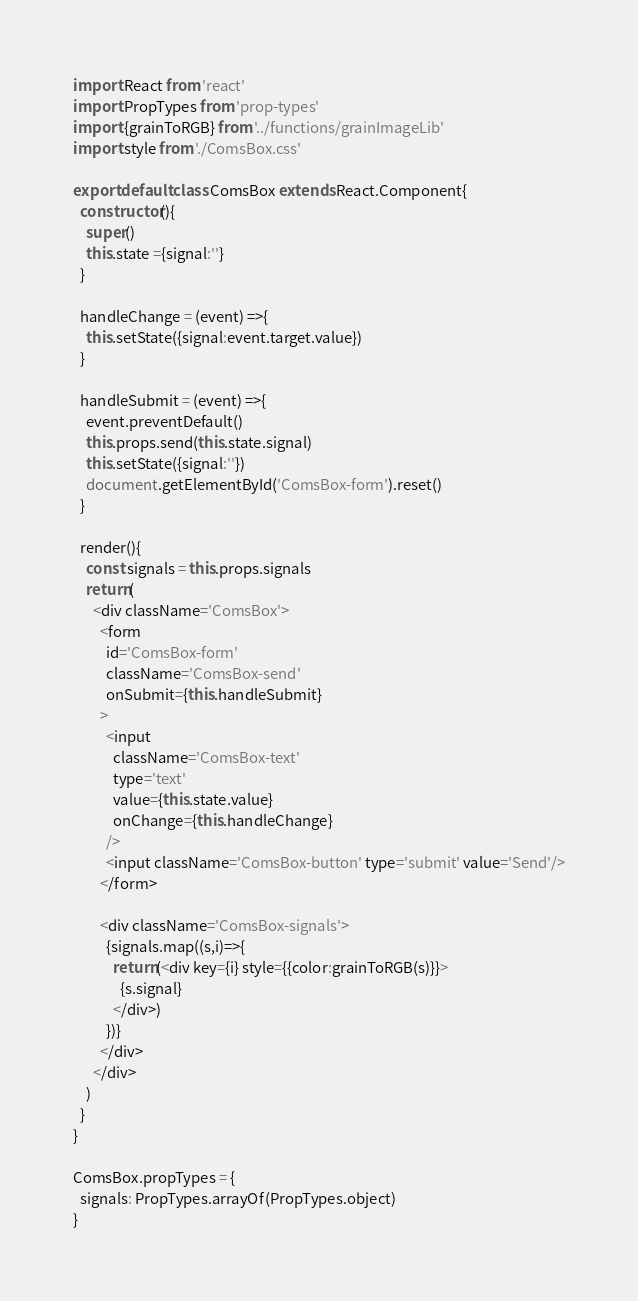<code> <loc_0><loc_0><loc_500><loc_500><_JavaScript_>import React from 'react'
import PropTypes from 'prop-types'
import {grainToRGB} from '../functions/grainImageLib'
import style from './ComsBox.css'

export default class ComsBox extends React.Component{
  constructor(){
    super()
    this.state ={signal:''}
  }

  handleChange = (event) =>{
    this.setState({signal:event.target.value})
  }
  
  handleSubmit = (event) =>{
    event.preventDefault()
    this.props.send(this.state.signal)
    this.setState({signal:''})
    document.getElementById('ComsBox-form').reset()
  }

  render(){
    const signals = this.props.signals
    return(
      <div className='ComsBox'>
        <form 
          id='ComsBox-form'
          className='ComsBox-send' 
          onSubmit={this.handleSubmit}
        >
          <input 
            className='ComsBox-text'
            type='text' 
            value={this.state.value}
            onChange={this.handleChange}
          />
          <input className='ComsBox-button' type='submit' value='Send'/>
        </form>
        
        <div className='ComsBox-signals'>
          {signals.map((s,i)=>{
            return(<div key={i} style={{color:grainToRGB(s)}}>
              {s.signal}
            </div>)
          })}
        </div>
      </div>
    )
  }
}

ComsBox.propTypes = {
  signals: PropTypes.arrayOf(PropTypes.object)
}</code> 